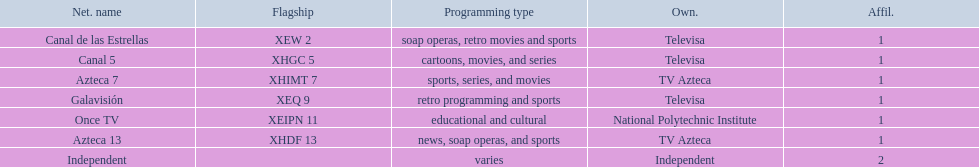What is the number of networks that are owned by televisa? 3. 